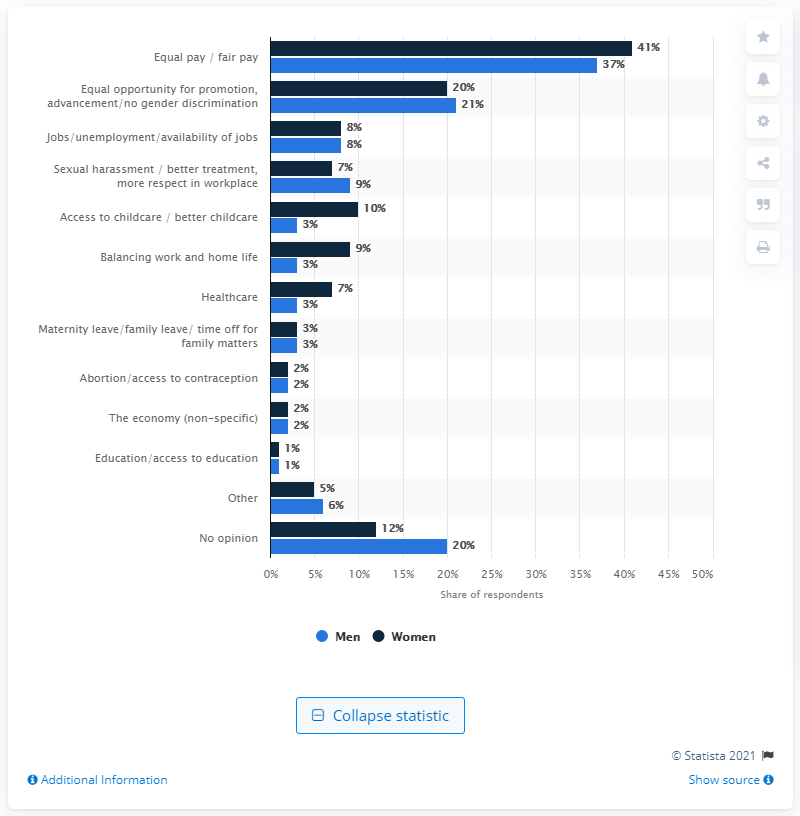Specify some key components in this picture. According to a survey, 41% of women believe that equal or fair pay is the most pressing issue facing working women in the United States today. According to a survey of men, 3% believed that access to childcare or improved childcare was the most significant concern for working women. 